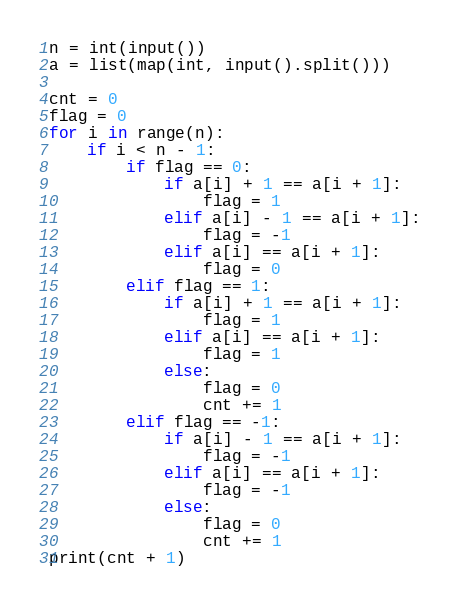<code> <loc_0><loc_0><loc_500><loc_500><_Python_>n = int(input())
a = list(map(int, input().split()))

cnt = 0
flag = 0
for i in range(n):
    if i < n - 1:
        if flag == 0:
            if a[i] + 1 == a[i + 1]:
                flag = 1
            elif a[i] - 1 == a[i + 1]:
                flag = -1
            elif a[i] == a[i + 1]:
                flag = 0
        elif flag == 1:
            if a[i] + 1 == a[i + 1]:
                flag = 1
            elif a[i] == a[i + 1]:
                flag = 1
            else:
                flag = 0
                cnt += 1
        elif flag == -1:
            if a[i] - 1 == a[i + 1]:
                flag = -1
            elif a[i] == a[i + 1]:
                flag = -1
            else:
                flag = 0
                cnt += 1
print(cnt + 1)
</code> 